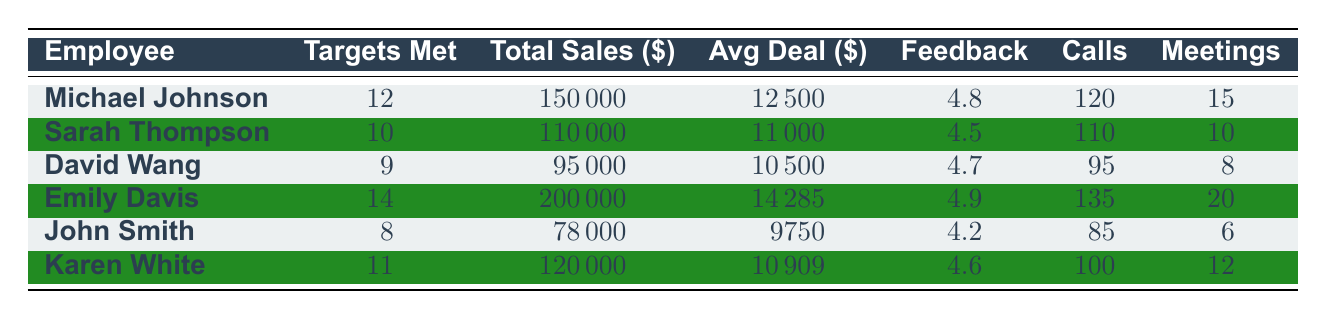What is the total sales generated by Emily Davis? Looking at Emily Davis's row, the total sales amount is provided in the table under the "Total Sales" column, which states $200,000.
Answer: 200000 Who has the highest average deal size? By comparing the "Avg Deal" column for each employee, we see that Emily Davis has an average deal size of $14,285, which is higher than that of others.
Answer: Emily Davis How many sales targets did Karen White meet? The row for Karen White indicates 11 sales targets met as per the "Targets Met" column.
Answer: 11 Is the customer feedback rating for Sarah Thompson higher than that for David Wang? Sarah Thompson has a feedback rating of 4.5, while David Wang has a rating of 4.7. Since 4.5 is less than 4.7, the statement is false.
Answer: No What is the average feedback rating of the sales team? To find the average feedback rating, sum all feedback ratings (4.8, 4.5, 4.7, 4.9, 4.2, 4.6) to get 28.7 and then divide by 6 (the number of employees): 28.7/6 ≈ 4.78.
Answer: Approximately 4.78 Who made the least number of calls? Looking at the "Calls" column, John Smith made the fewest calls with a total of 85 calls.
Answer: John Smith What is the difference in total sales between Michael Johnson and John Smith? The total sales for Michael Johnson are $150,000, and for John Smith, it is $78,000. The difference is calculated as $150,000 - $78,000 = $72,000.
Answer: 72000 How many more meetings did Emily Davis attend compared to David Wang? Emily Davis attended 20 meetings while David Wang attended 8. The difference is 20 - 8 = 12 meetings.
Answer: 12 Which employee met more than 10 sales targets? By examining the "Targets Met" column, Michael Johnson (12), Emily Davis (14), and Karen White (11) all met more than 10 sales targets.
Answer: Michael Johnson, Emily Davis, Karen White What is the median average deal size of the employees? First, we list the average deal sizes: 12500, 11000, 10500, 14285, 9750, 10909. Ordering these, we get 9750, 10500, 11000, 10909, 12500, 14285. The median is the average of the 3rd and 4th value: (11000 + 10909) / 2 = 10954.5.
Answer: 10954.5 